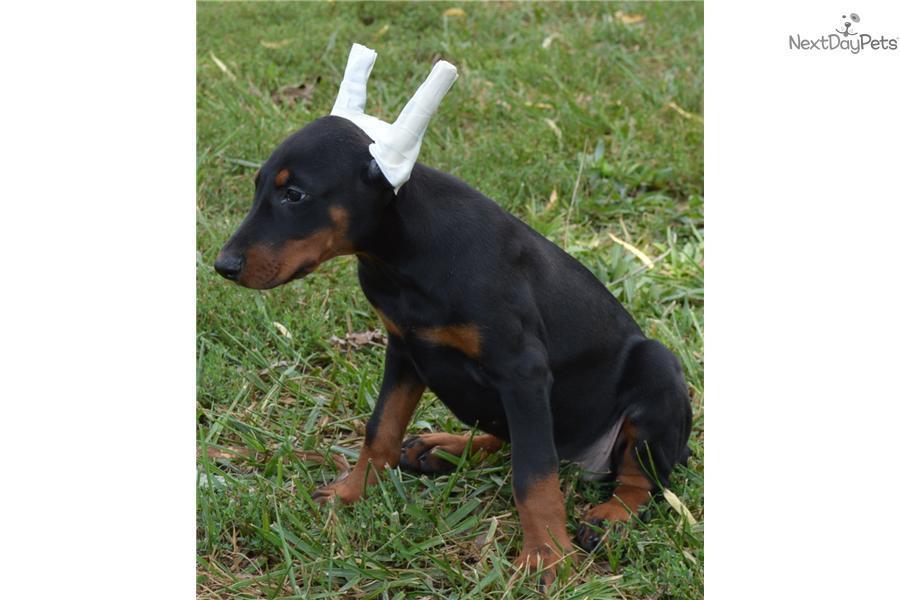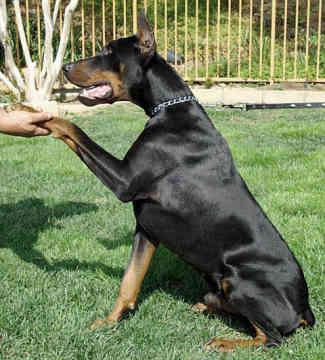The first image is the image on the left, the second image is the image on the right. For the images displayed, is the sentence "A dog has one paw off the ground." factually correct? Answer yes or no. Yes. The first image is the image on the left, the second image is the image on the right. For the images shown, is this caption "One image contains a doberman sitting upright with its body turned leftward, and the other image features a doberman sitting upright with one front paw raised." true? Answer yes or no. Yes. 